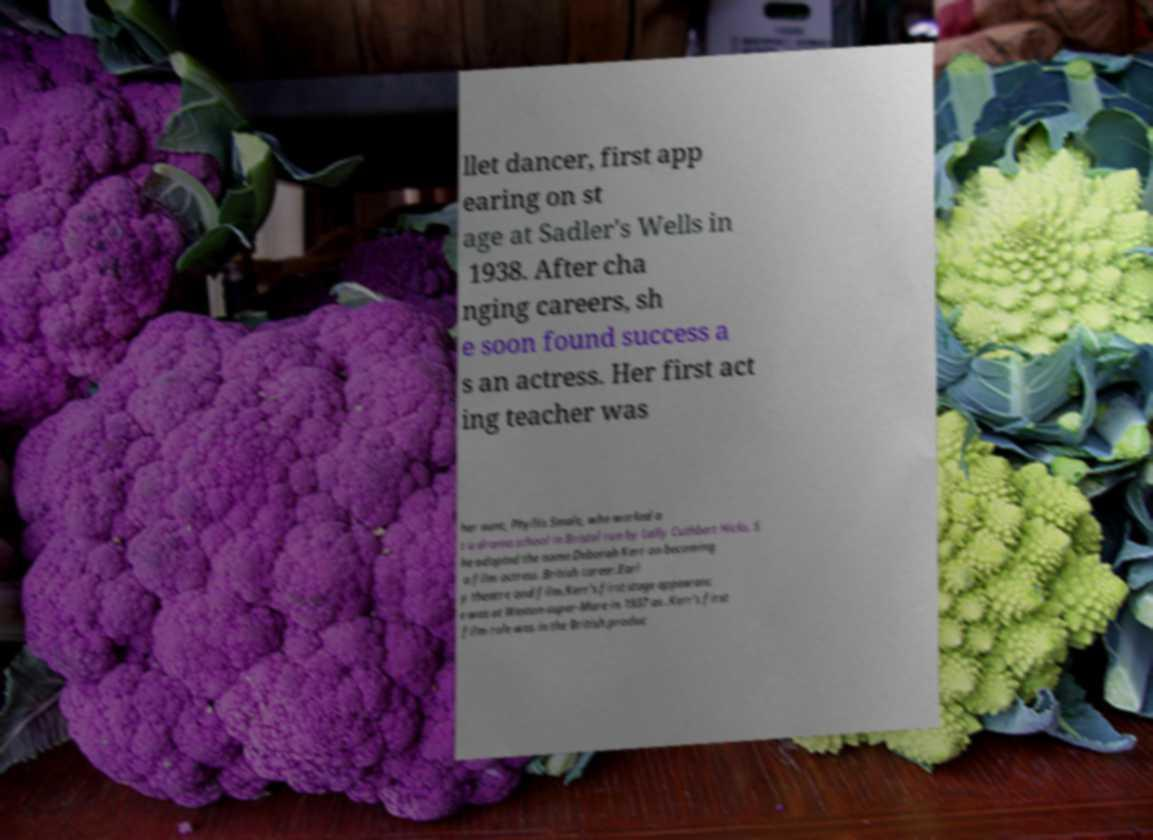Can you accurately transcribe the text from the provided image for me? llet dancer, first app earing on st age at Sadler's Wells in 1938. After cha nging careers, sh e soon found success a s an actress. Her first act ing teacher was her aunt, Phyllis Smale, who worked a t a drama school in Bristol run by Lally Cuthbert Hicks. S he adopted the name Deborah Kerr on becoming a film actress .British career.Earl y theatre and film.Kerr's first stage appearanc e was at Weston-super-Mare in 1937 as .Kerr's first film role was in the British produc 